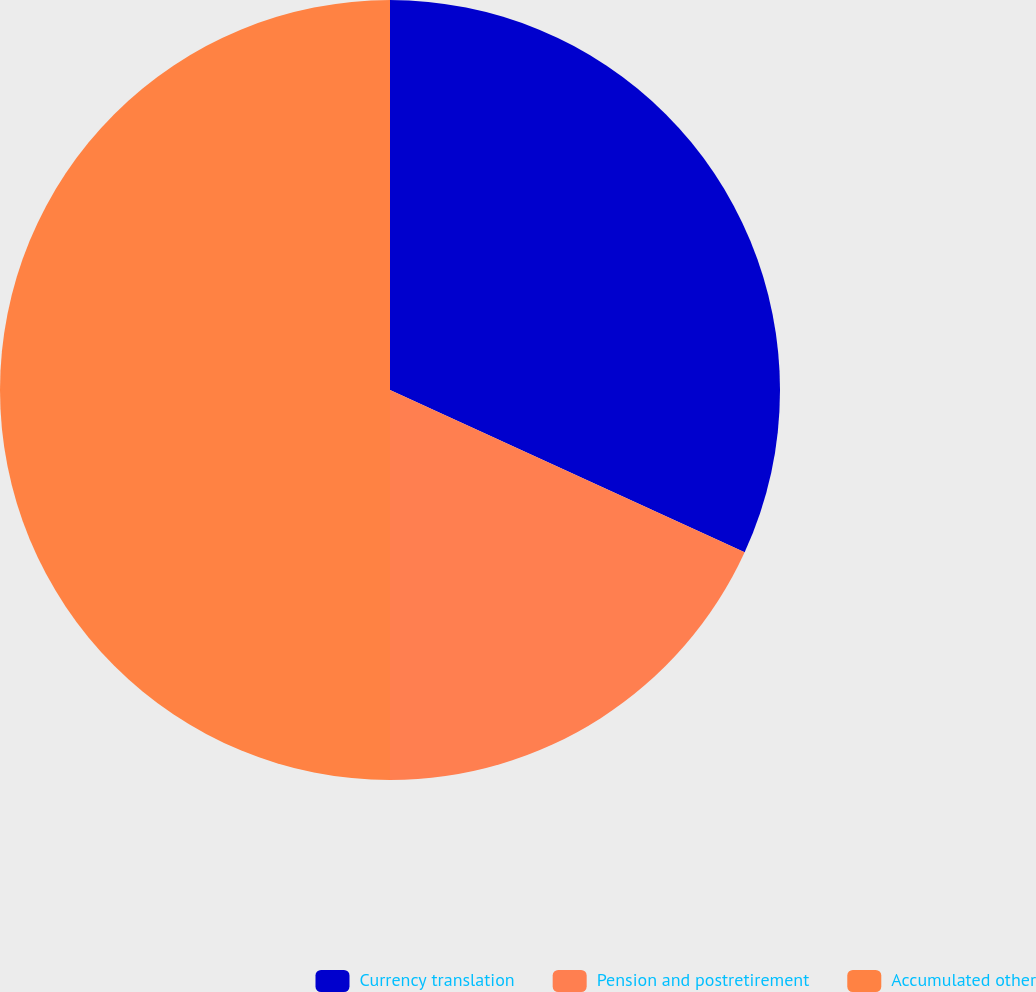<chart> <loc_0><loc_0><loc_500><loc_500><pie_chart><fcel>Currency translation<fcel>Pension and postretirement<fcel>Accumulated other<nl><fcel>31.83%<fcel>18.17%<fcel>50.0%<nl></chart> 